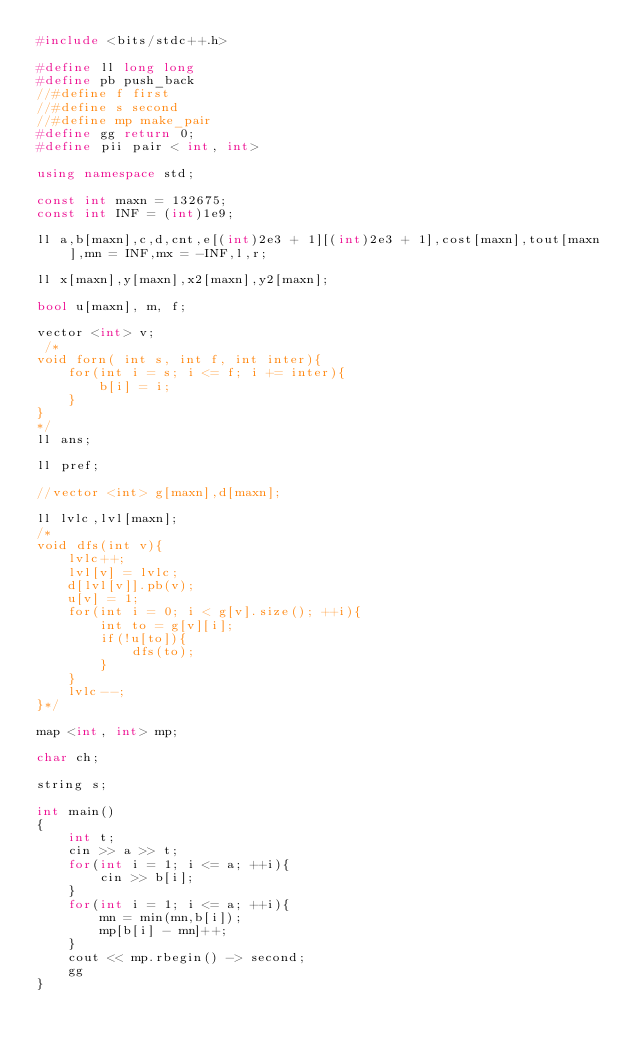<code> <loc_0><loc_0><loc_500><loc_500><_C++_>#include <bits/stdc++.h>
 
#define ll long long
#define pb push_back
//#define f first
//#define s second
//#define mp make_pair
#define gg return 0;
#define pii pair < int, int>
 
using namespace std;
 
const int maxn = 132675;
const int INF = (int)1e9;
 
ll a,b[maxn],c,d,cnt,e[(int)2e3 + 1][(int)2e3 + 1],cost[maxn],tout[maxn],mn = INF,mx = -INF,l,r;
 
ll x[maxn],y[maxn],x2[maxn],y2[maxn];
 
bool u[maxn], m, f;
 
vector <int> v;
 /*
void forn( int s, int f, int inter){
	for(int i = s; i <= f; i += inter){
		b[i] = i;
	}
}
*/ 
ll ans;
 
ll pref;
 
//vector <int> g[maxn],d[maxn];
 
ll lvlc,lvl[maxn];
/*
void dfs(int v){
	lvlc++;
	lvl[v] = lvlc;
	d[lvl[v]].pb(v);
	u[v] = 1;
	for(int i = 0; i < g[v].size(); ++i){
		int to = g[v][i];
		if(!u[to]){
			dfs(to);
		}
	}
	lvlc--;
}*/

map <int, int> mp; 
 
char ch;

string s; 

int main()
{
	int t;
	cin >> a >> t;
	for(int i = 1; i <= a; ++i){
		cin >> b[i];
	}
	for(int i = 1; i <= a; ++i){
		mn = min(mn,b[i]);
		mp[b[i] - mn]++;
	}
	cout << mp.rbegin() -> second;
	gg
}</code> 